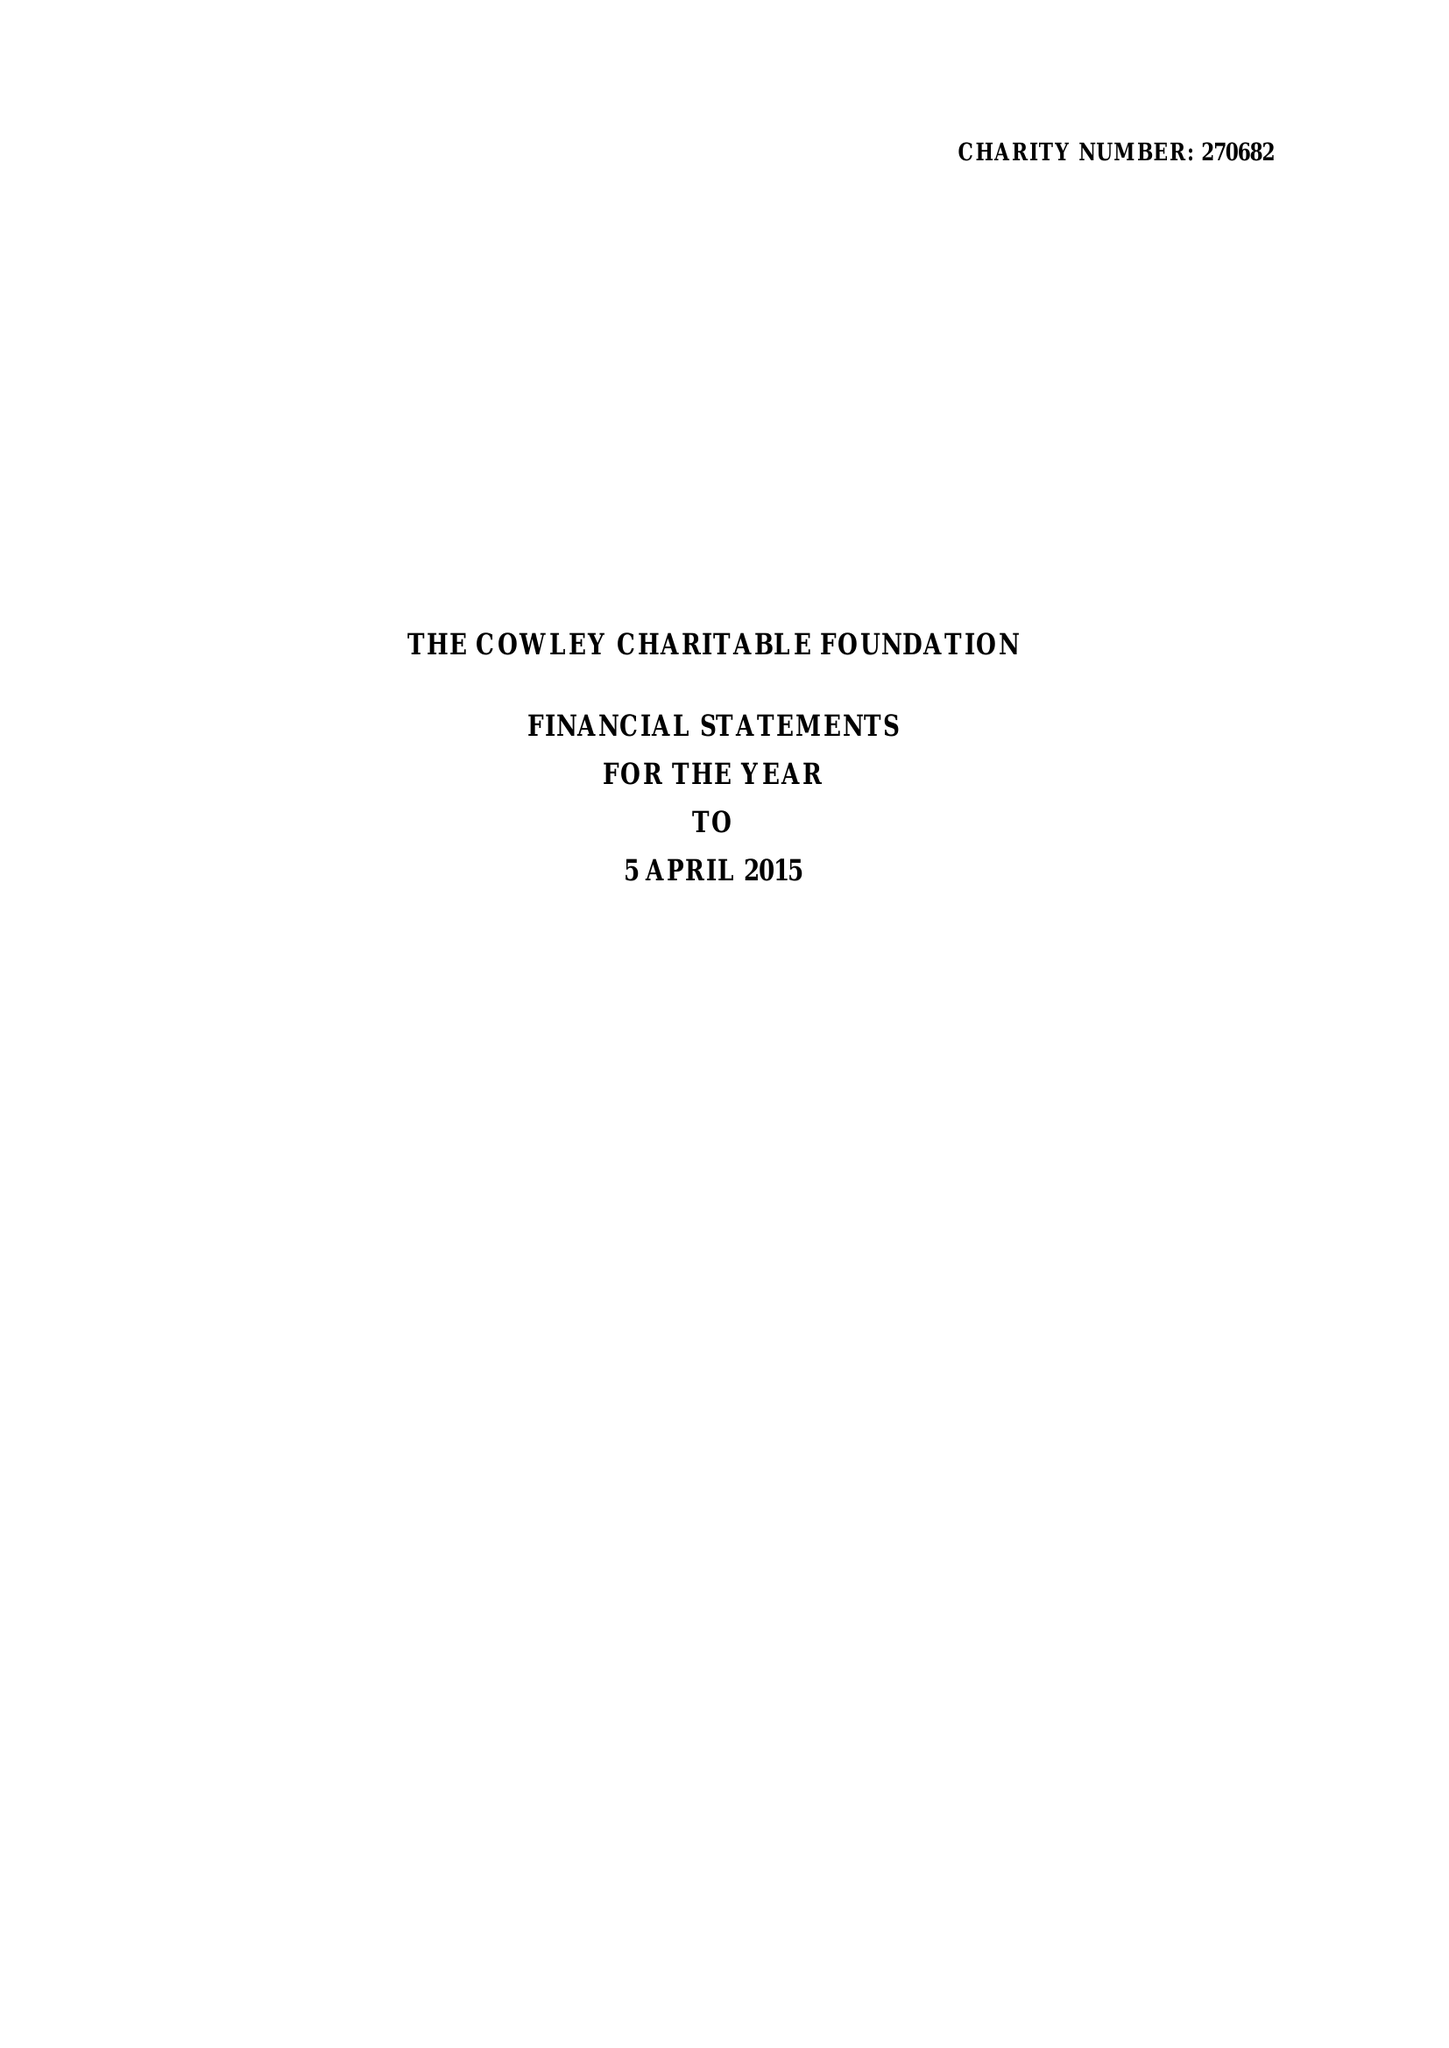What is the value for the spending_annually_in_british_pounds?
Answer the question using a single word or phrase. 35019.00 